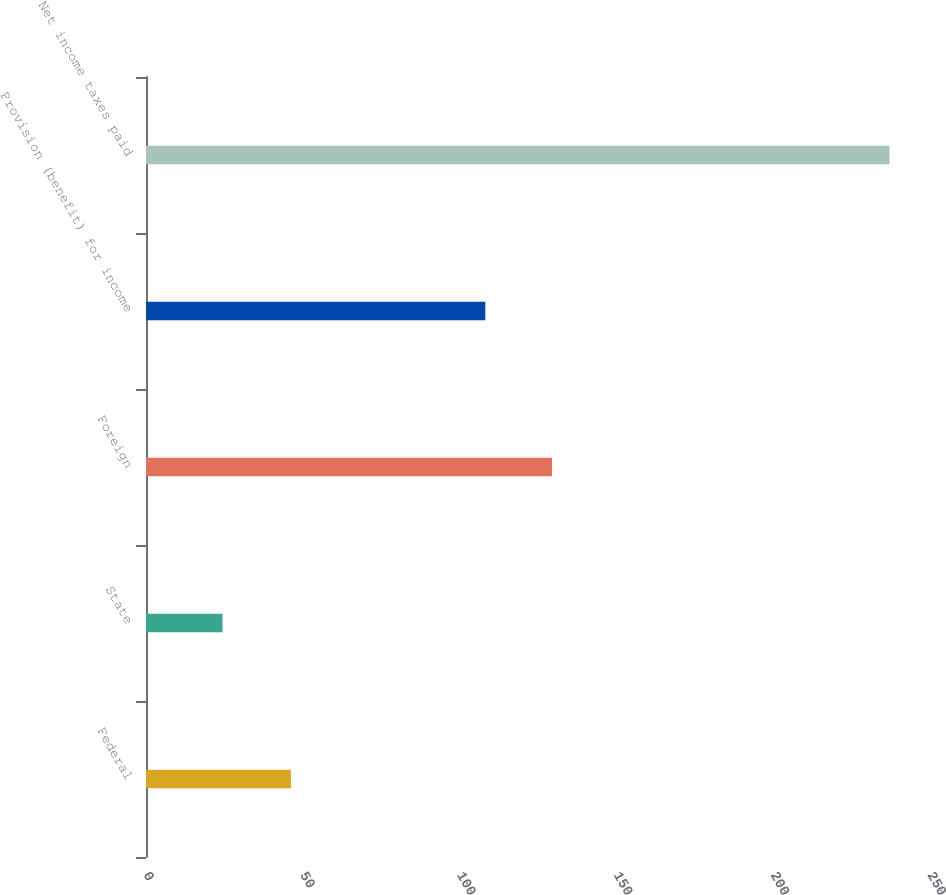Convert chart to OTSL. <chart><loc_0><loc_0><loc_500><loc_500><bar_chart><fcel>Federal<fcel>State<fcel>Foreign<fcel>Provision (benefit) for income<fcel>Net income taxes paid<nl><fcel>46.2<fcel>24.4<fcel>129.47<fcel>108.2<fcel>237.1<nl></chart> 